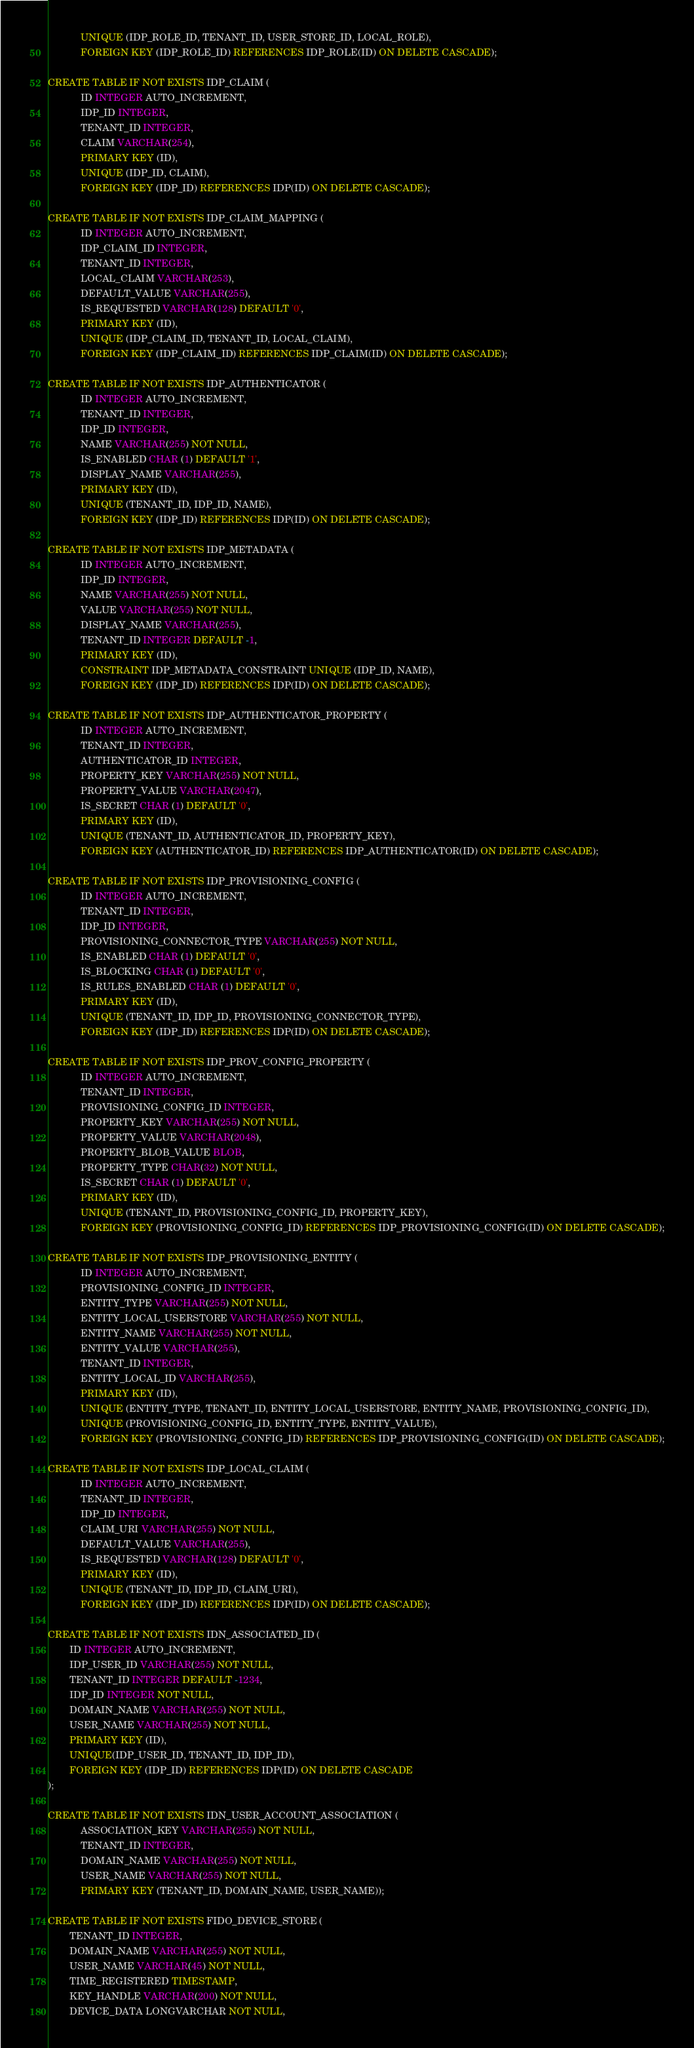Convert code to text. <code><loc_0><loc_0><loc_500><loc_500><_SQL_>			UNIQUE (IDP_ROLE_ID, TENANT_ID, USER_STORE_ID, LOCAL_ROLE),
			FOREIGN KEY (IDP_ROLE_ID) REFERENCES IDP_ROLE(ID) ON DELETE CASCADE);

CREATE TABLE IF NOT EXISTS IDP_CLAIM (
			ID INTEGER AUTO_INCREMENT,
			IDP_ID INTEGER,
			TENANT_ID INTEGER,
			CLAIM VARCHAR(254),
			PRIMARY KEY (ID),
			UNIQUE (IDP_ID, CLAIM),
			FOREIGN KEY (IDP_ID) REFERENCES IDP(ID) ON DELETE CASCADE);

CREATE TABLE IF NOT EXISTS IDP_CLAIM_MAPPING (
			ID INTEGER AUTO_INCREMENT,
			IDP_CLAIM_ID INTEGER,
			TENANT_ID INTEGER,
			LOCAL_CLAIM VARCHAR(253),
			DEFAULT_VALUE VARCHAR(255),
			IS_REQUESTED VARCHAR(128) DEFAULT '0',
			PRIMARY KEY (ID),
			UNIQUE (IDP_CLAIM_ID, TENANT_ID, LOCAL_CLAIM),
			FOREIGN KEY (IDP_CLAIM_ID) REFERENCES IDP_CLAIM(ID) ON DELETE CASCADE);

CREATE TABLE IF NOT EXISTS IDP_AUTHENTICATOR (
            ID INTEGER AUTO_INCREMENT,
            TENANT_ID INTEGER,
            IDP_ID INTEGER,
            NAME VARCHAR(255) NOT NULL,
            IS_ENABLED CHAR (1) DEFAULT '1',
            DISPLAY_NAME VARCHAR(255),
            PRIMARY KEY (ID),
            UNIQUE (TENANT_ID, IDP_ID, NAME),
            FOREIGN KEY (IDP_ID) REFERENCES IDP(ID) ON DELETE CASCADE);

CREATE TABLE IF NOT EXISTS IDP_METADATA (
            ID INTEGER AUTO_INCREMENT,
            IDP_ID INTEGER,
            NAME VARCHAR(255) NOT NULL,
            VALUE VARCHAR(255) NOT NULL,
            DISPLAY_NAME VARCHAR(255),
            TENANT_ID INTEGER DEFAULT -1,
            PRIMARY KEY (ID),
            CONSTRAINT IDP_METADATA_CONSTRAINT UNIQUE (IDP_ID, NAME),
            FOREIGN KEY (IDP_ID) REFERENCES IDP(ID) ON DELETE CASCADE);

CREATE TABLE IF NOT EXISTS IDP_AUTHENTICATOR_PROPERTY (
            ID INTEGER AUTO_INCREMENT,
            TENANT_ID INTEGER,
            AUTHENTICATOR_ID INTEGER,
            PROPERTY_KEY VARCHAR(255) NOT NULL,
            PROPERTY_VALUE VARCHAR(2047),
            IS_SECRET CHAR (1) DEFAULT '0',
            PRIMARY KEY (ID),
            UNIQUE (TENANT_ID, AUTHENTICATOR_ID, PROPERTY_KEY),
            FOREIGN KEY (AUTHENTICATOR_ID) REFERENCES IDP_AUTHENTICATOR(ID) ON DELETE CASCADE);

CREATE TABLE IF NOT EXISTS IDP_PROVISIONING_CONFIG (
            ID INTEGER AUTO_INCREMENT,
            TENANT_ID INTEGER,
            IDP_ID INTEGER,
            PROVISIONING_CONNECTOR_TYPE VARCHAR(255) NOT NULL,
            IS_ENABLED CHAR (1) DEFAULT '0',
            IS_BLOCKING CHAR (1) DEFAULT '0',
            IS_RULES_ENABLED CHAR (1) DEFAULT '0',
            PRIMARY KEY (ID),
            UNIQUE (TENANT_ID, IDP_ID, PROVISIONING_CONNECTOR_TYPE),
            FOREIGN KEY (IDP_ID) REFERENCES IDP(ID) ON DELETE CASCADE);

CREATE TABLE IF NOT EXISTS IDP_PROV_CONFIG_PROPERTY (
            ID INTEGER AUTO_INCREMENT,
            TENANT_ID INTEGER,
            PROVISIONING_CONFIG_ID INTEGER,
            PROPERTY_KEY VARCHAR(255) NOT NULL,
            PROPERTY_VALUE VARCHAR(2048),
            PROPERTY_BLOB_VALUE BLOB,
            PROPERTY_TYPE CHAR(32) NOT NULL,
            IS_SECRET CHAR (1) DEFAULT '0',
            PRIMARY KEY (ID),
            UNIQUE (TENANT_ID, PROVISIONING_CONFIG_ID, PROPERTY_KEY),
            FOREIGN KEY (PROVISIONING_CONFIG_ID) REFERENCES IDP_PROVISIONING_CONFIG(ID) ON DELETE CASCADE);

CREATE TABLE IF NOT EXISTS IDP_PROVISIONING_ENTITY (
            ID INTEGER AUTO_INCREMENT,
            PROVISIONING_CONFIG_ID INTEGER,
            ENTITY_TYPE VARCHAR(255) NOT NULL,
            ENTITY_LOCAL_USERSTORE VARCHAR(255) NOT NULL,
            ENTITY_NAME VARCHAR(255) NOT NULL,
            ENTITY_VALUE VARCHAR(255),
            TENANT_ID INTEGER,
            ENTITY_LOCAL_ID VARCHAR(255),
            PRIMARY KEY (ID),
            UNIQUE (ENTITY_TYPE, TENANT_ID, ENTITY_LOCAL_USERSTORE, ENTITY_NAME, PROVISIONING_CONFIG_ID),
            UNIQUE (PROVISIONING_CONFIG_ID, ENTITY_TYPE, ENTITY_VALUE),
            FOREIGN KEY (PROVISIONING_CONFIG_ID) REFERENCES IDP_PROVISIONING_CONFIG(ID) ON DELETE CASCADE);

CREATE TABLE IF NOT EXISTS IDP_LOCAL_CLAIM (
            ID INTEGER AUTO_INCREMENT,
            TENANT_ID INTEGER,
            IDP_ID INTEGER,
            CLAIM_URI VARCHAR(255) NOT NULL,
            DEFAULT_VALUE VARCHAR(255),
            IS_REQUESTED VARCHAR(128) DEFAULT '0',
            PRIMARY KEY (ID),
            UNIQUE (TENANT_ID, IDP_ID, CLAIM_URI),
            FOREIGN KEY (IDP_ID) REFERENCES IDP(ID) ON DELETE CASCADE);

CREATE TABLE IF NOT EXISTS IDN_ASSOCIATED_ID (
	    ID INTEGER AUTO_INCREMENT,
	    IDP_USER_ID VARCHAR(255) NOT NULL,
	    TENANT_ID INTEGER DEFAULT -1234,
	    IDP_ID INTEGER NOT NULL,
	    DOMAIN_NAME VARCHAR(255) NOT NULL,
 	    USER_NAME VARCHAR(255) NOT NULL,
	    PRIMARY KEY (ID),
	    UNIQUE(IDP_USER_ID, TENANT_ID, IDP_ID),
	    FOREIGN KEY (IDP_ID) REFERENCES IDP(ID) ON DELETE CASCADE
);

CREATE TABLE IF NOT EXISTS IDN_USER_ACCOUNT_ASSOCIATION (
            ASSOCIATION_KEY VARCHAR(255) NOT NULL,
            TENANT_ID INTEGER,
            DOMAIN_NAME VARCHAR(255) NOT NULL,
            USER_NAME VARCHAR(255) NOT NULL,
            PRIMARY KEY (TENANT_ID, DOMAIN_NAME, USER_NAME));

CREATE TABLE IF NOT EXISTS FIDO_DEVICE_STORE (
        TENANT_ID INTEGER,
        DOMAIN_NAME VARCHAR(255) NOT NULL,
        USER_NAME VARCHAR(45) NOT NULL,
        TIME_REGISTERED TIMESTAMP,
        KEY_HANDLE VARCHAR(200) NOT NULL,
        DEVICE_DATA LONGVARCHAR NOT NULL,</code> 